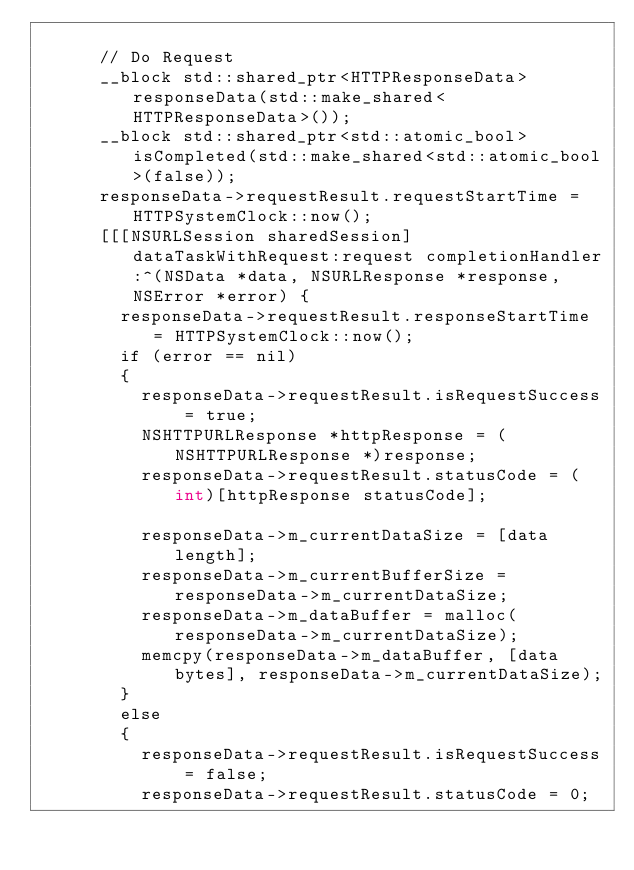<code> <loc_0><loc_0><loc_500><loc_500><_ObjectiveC_>			
			// Do Request
			__block std::shared_ptr<HTTPResponseData> responseData(std::make_shared<HTTPResponseData>());
			__block std::shared_ptr<std::atomic_bool> isCompleted(std::make_shared<std::atomic_bool>(false));
			responseData->requestResult.requestStartTime = HTTPSystemClock::now();
			[[[NSURLSession sharedSession] dataTaskWithRequest:request completionHandler:^(NSData *data, NSURLResponse *response, NSError *error) {
				responseData->requestResult.responseStartTime = HTTPSystemClock::now();
				if (error == nil)
				{
					responseData->requestResult.isRequestSuccess = true;
					NSHTTPURLResponse *httpResponse = (NSHTTPURLResponse *)response;
					responseData->requestResult.statusCode = (int)[httpResponse statusCode];
					
					responseData->m_currentDataSize = [data length];
					responseData->m_currentBufferSize = responseData->m_currentDataSize;
					responseData->m_dataBuffer = malloc(responseData->m_currentDataSize);
					memcpy(responseData->m_dataBuffer, [data bytes], responseData->m_currentDataSize);
				}
				else
				{
					responseData->requestResult.isRequestSuccess = false;
					responseData->requestResult.statusCode = 0;</code> 